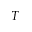Convert formula to latex. <formula><loc_0><loc_0><loc_500><loc_500>T</formula> 